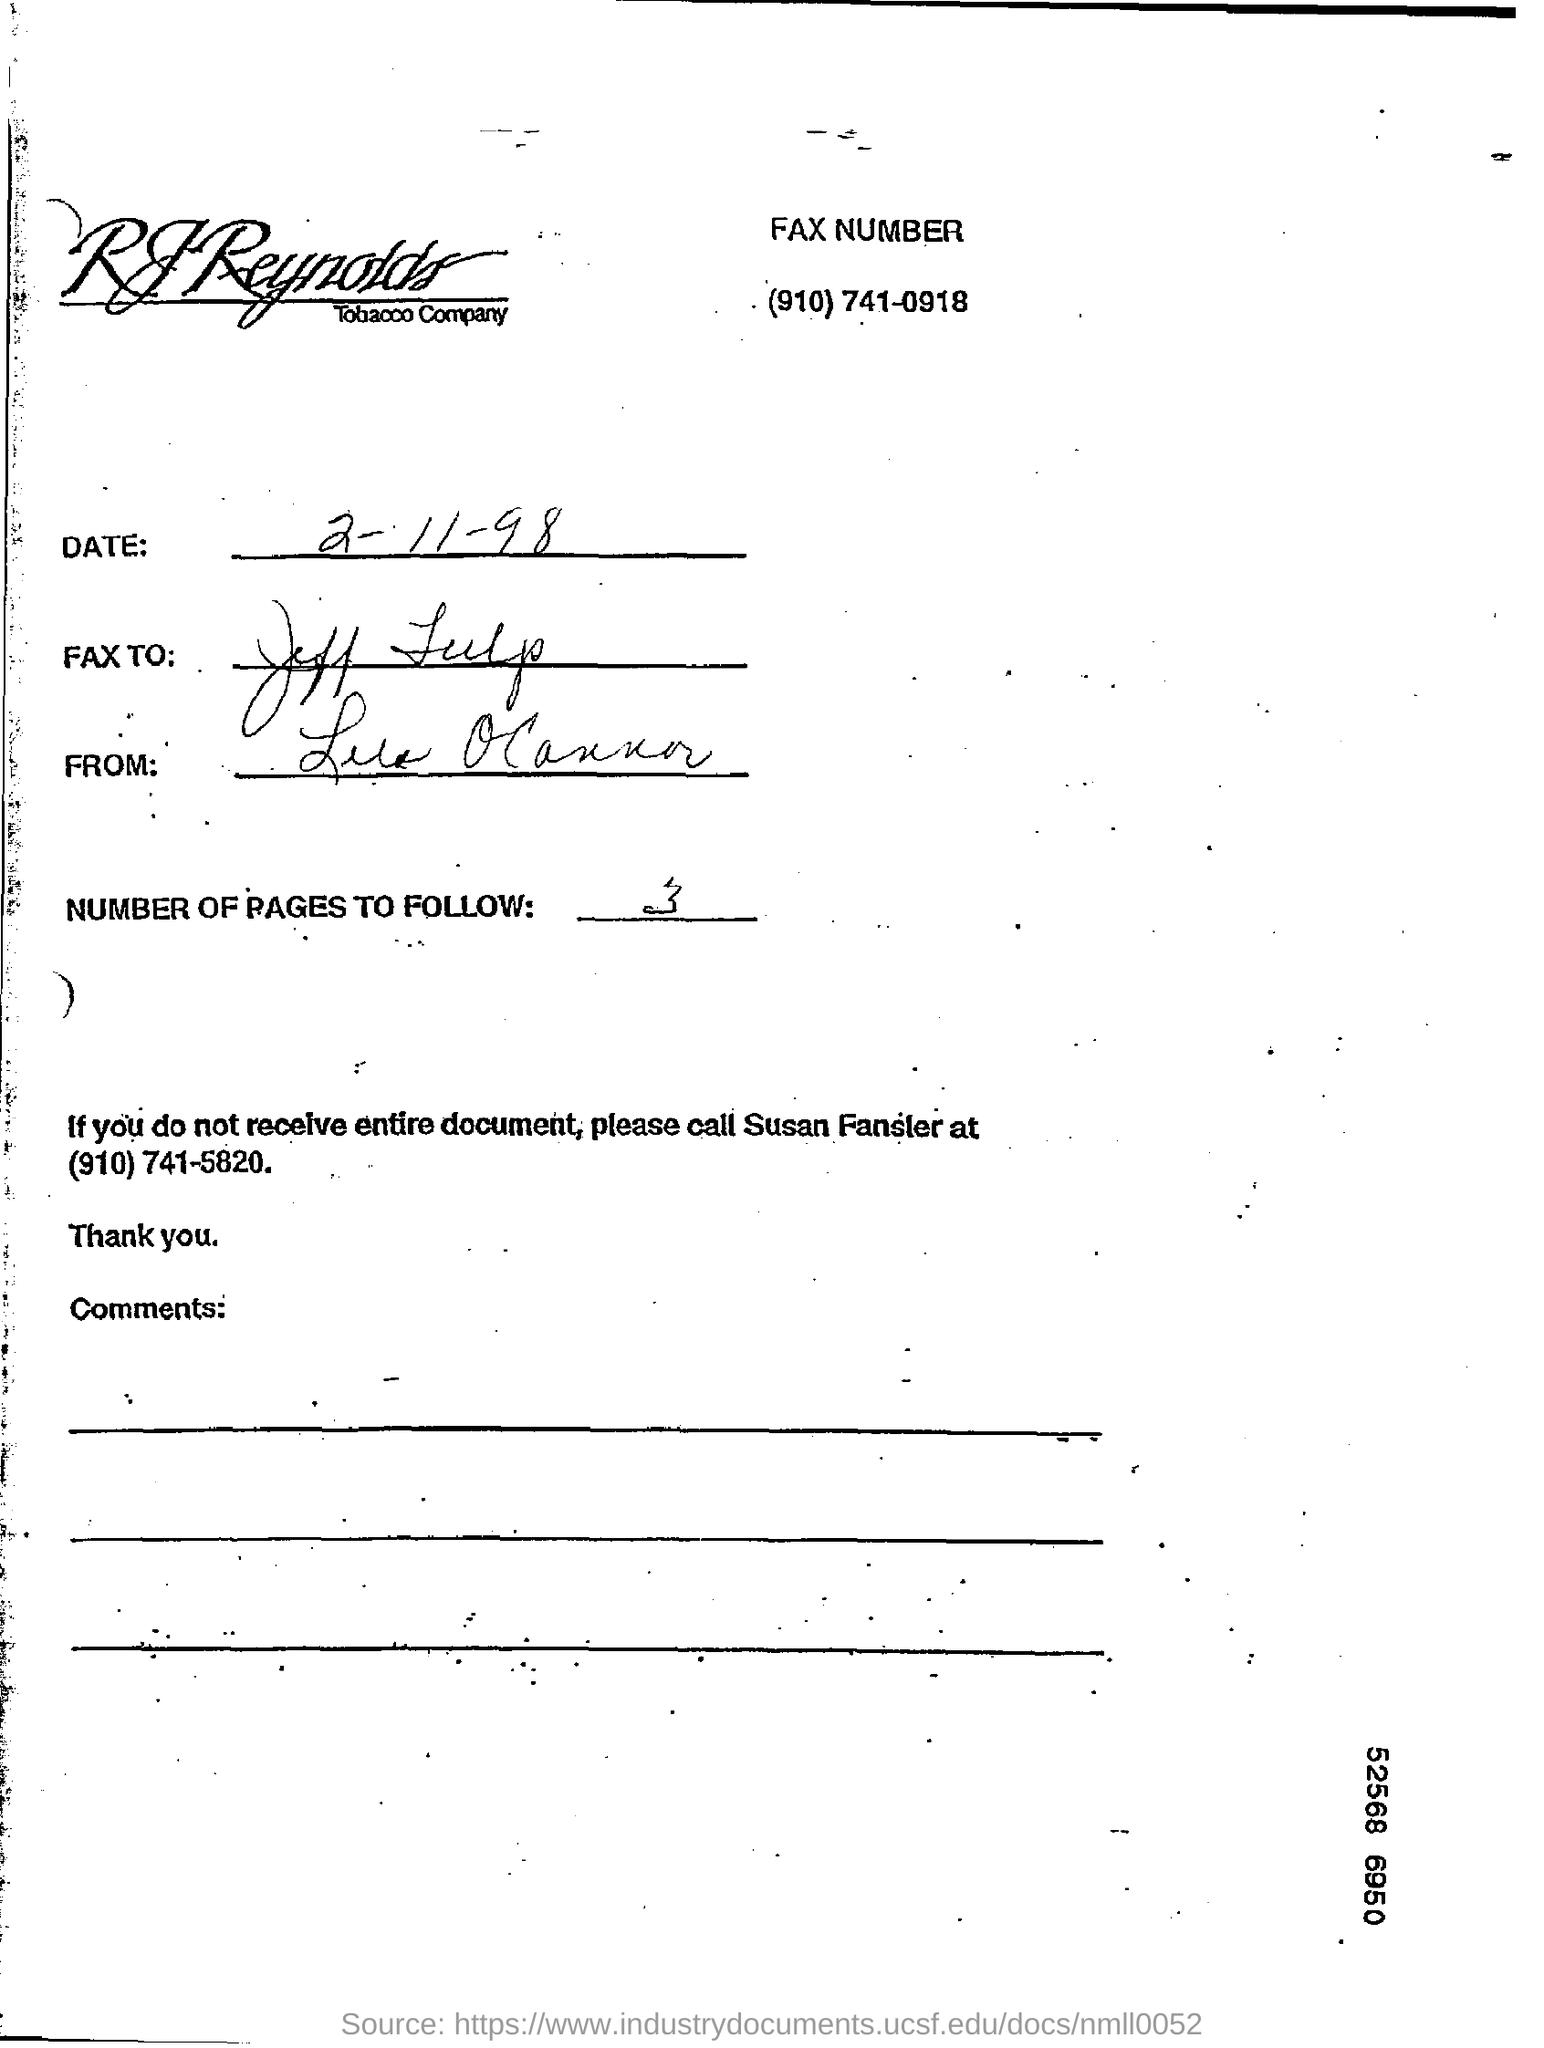What is the Date?
Offer a very short reply. 2-11-98. What are the Number of Pages to follow?
Make the answer very short. 3. 